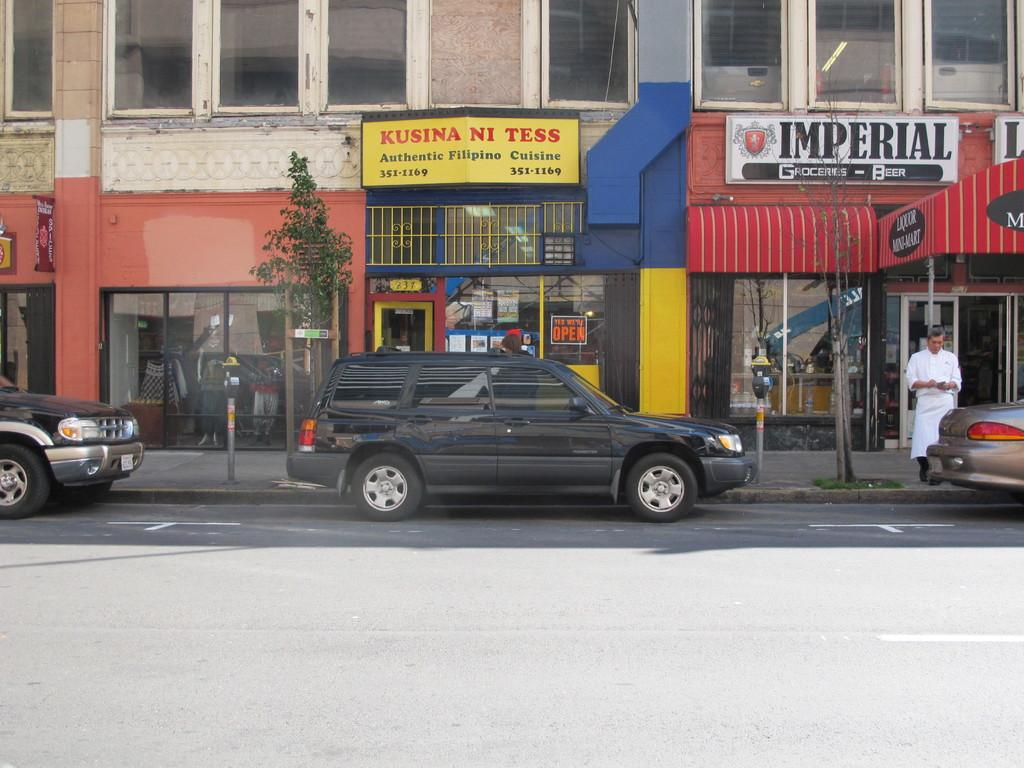What can be found inside the building in the image? There are vehicles in the building. What is happening outside the building? There is a person on a path outside the building. Can you describe the building in the image? There is a building in the image. What else can be seen inside the building besides the vehicles? There are objects or features visible inside the building. What type of sweater is the person wearing in the image? There is no person wearing a sweater in the image; the person is on a path outside the building. Can you tell me where the market is located in the image? There is no market present in the image; it features a building with vehicles inside and a person on a path outside. 